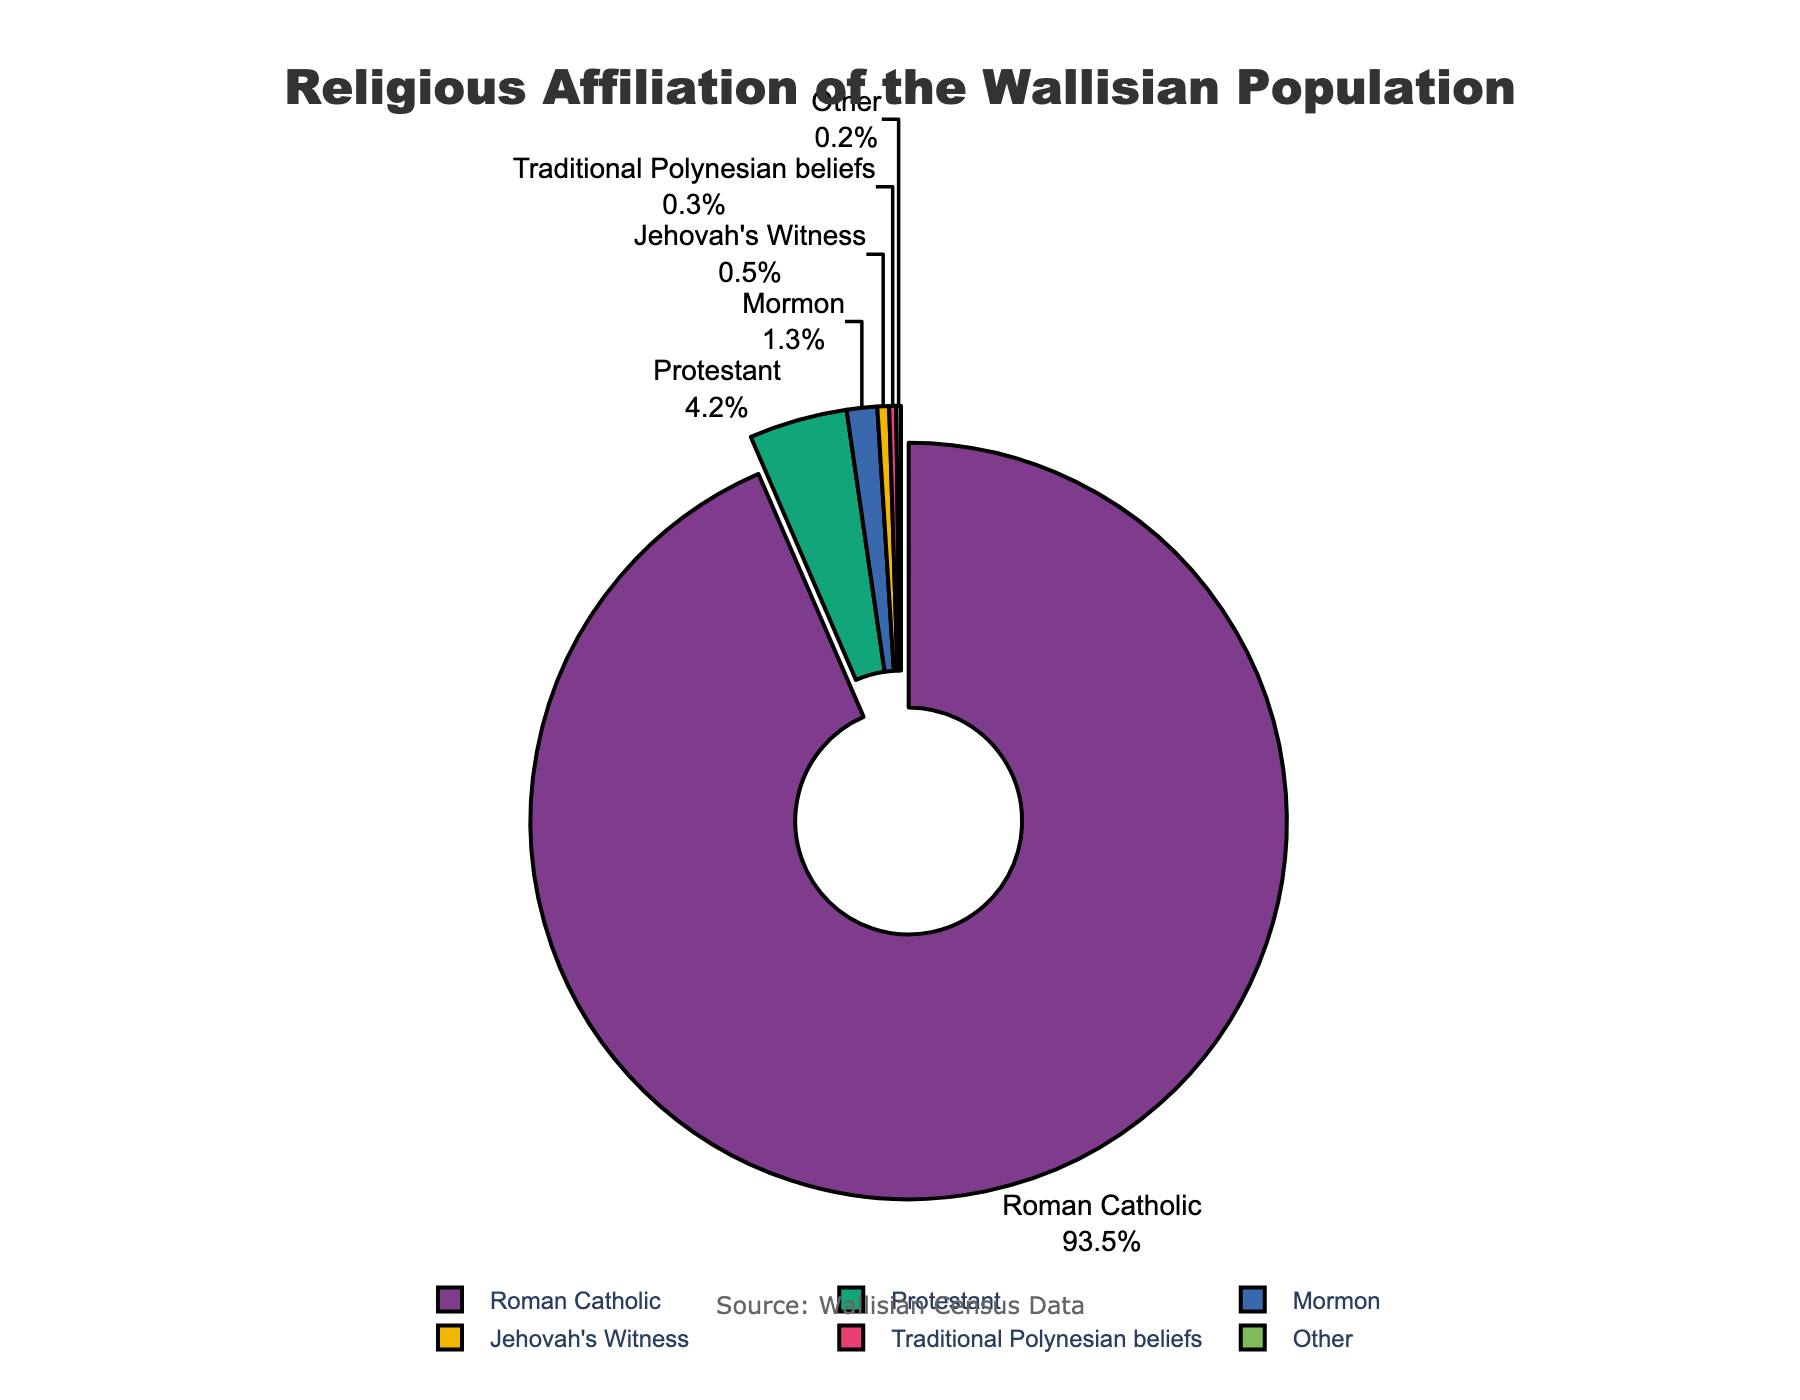Which religion has the largest percentage of followers amongst the Wallisian population? The figure shows a pie chart of the religious affiliation of the Wallisian population. The largest segment corresponds to Roman Catholic, with the largest percentage in the chart.
Answer: Roman Catholic What is the combined percentage of Protestant and Mormon followers? To find the combined percentage, add the percentage for Protestant (4.2%) and Mormon (1.3%). The combined percentage is 4.2% + 1.3% = 5.5%.
Answer: 5.5% Which segment is highlighted in the pie chart? The pie chart’s description mentions a segment pulled out for emphasis. The largest percentage segment (Roman Catholic, 93.5%) has this highlighting.
Answer: Roman Catholic How much more significant is the Roman Catholic segment compared to the Protestant segment? The percentage for Roman Catholic is 93.5%, and for Protestant is 4.2%. Subtract the Protestant percentage from the Roman Catholic percentage: 93.5% - 4.2% = 89.3%.
Answer: 89.3% How do the percentages of Mormon and Jehovah's Witness followers compare? Observe the percentages for Mormon (1.3%) and Jehovah's Witness (0.5%). The Mormon percentage is greater than Jehovah's Witness by 1.3% - 0.5% = 0.8%.
Answer: 0.8% What is the total percentage represented by religious affiliations other than Roman Catholic? Subtract the Roman Catholic percentage (93.5%) from 100% to find the total for all other affiliations: 100% - 93.5% = 6.5%.
Answer: 6.5% What is the difference between the Protestant and Traditional Polynesian beliefs percentages? The pie chart shows 4.2% for Protestant and 0.3% for Traditional Polynesian beliefs. The difference is 4.2% - 0.3% = 3.9%.
Answer: 3.9% Identify the religion with the smallest proportion of adherents. The smallest percentage segment in the pie chart is for "Other" which has 0.2%.
Answer: Other How many religions have a percentage greater than 1%? Scan the pie chart for segments greater than 1%. They are Roman Catholic (93.5%), Protestant (4.2%), and Mormon (1.3%). There are three such religions.
Answer: 3 